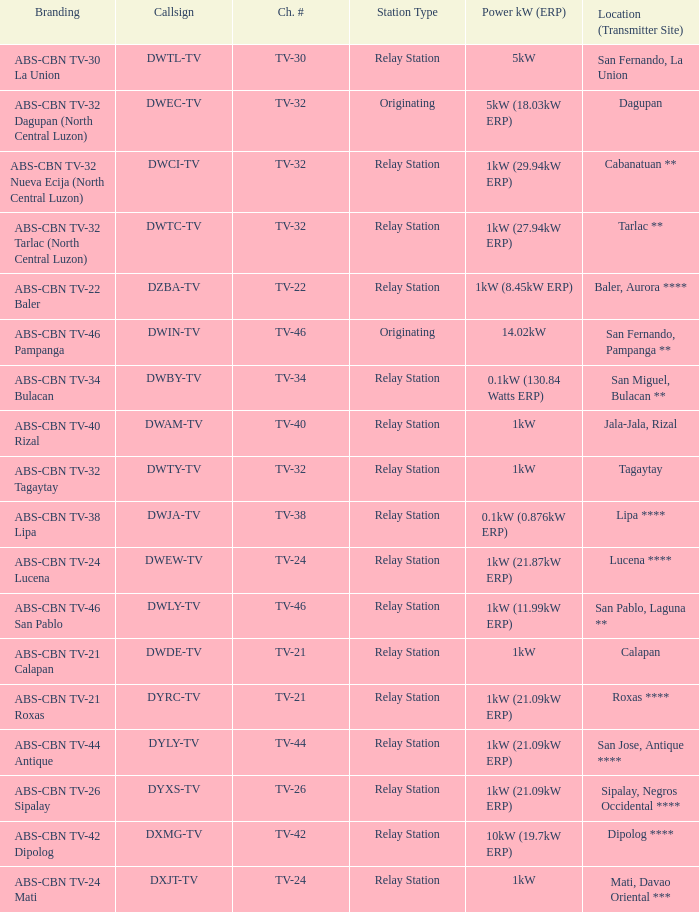What is the station type for the branding ABS-CBN TV-32 Tagaytay? Relay Station. 